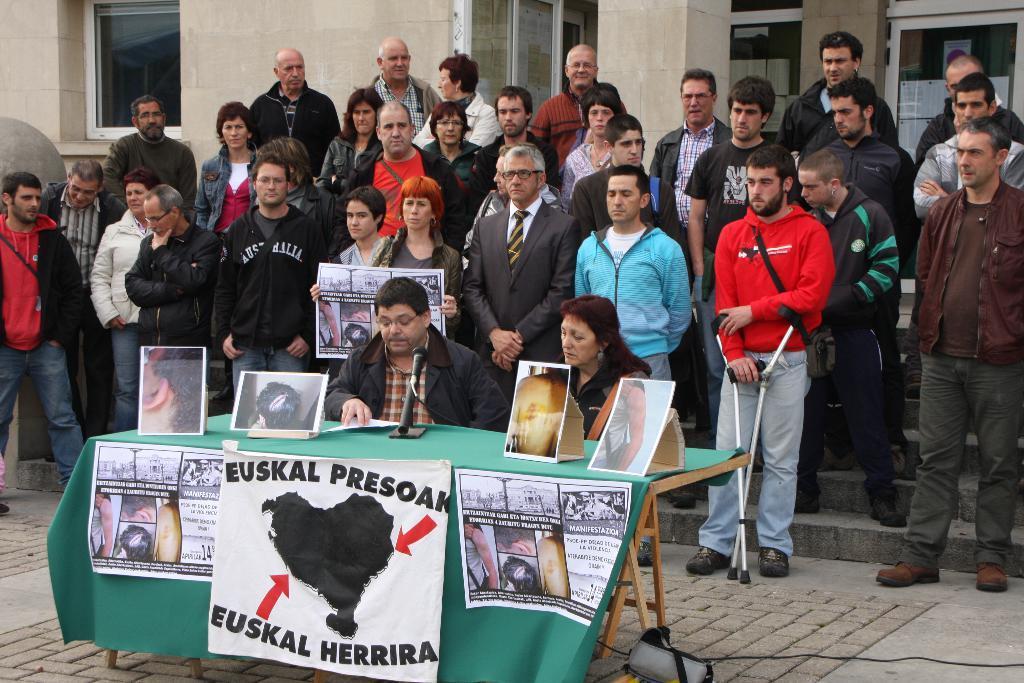In one or two sentences, can you explain what this image depicts? This picture is clicked outside. In the foreground we can see the two people sitting on the chairs and we can see the posters containing the depictions of persons and depictions of some objects are placed on the top of the table and we can see a microphone is placed on the top of the table and we can see the posters containing the depictions of people and the depictions of some other objects and text are hanging on the table cloth. In the center we can see the group of people standing on the stairs and the group of people standing on the ground and we can see a person holding a poster and standing. In the background we can see the building. On the right we can see a man wearing a sling bag, standing on the ground and holding the hand sticks. 